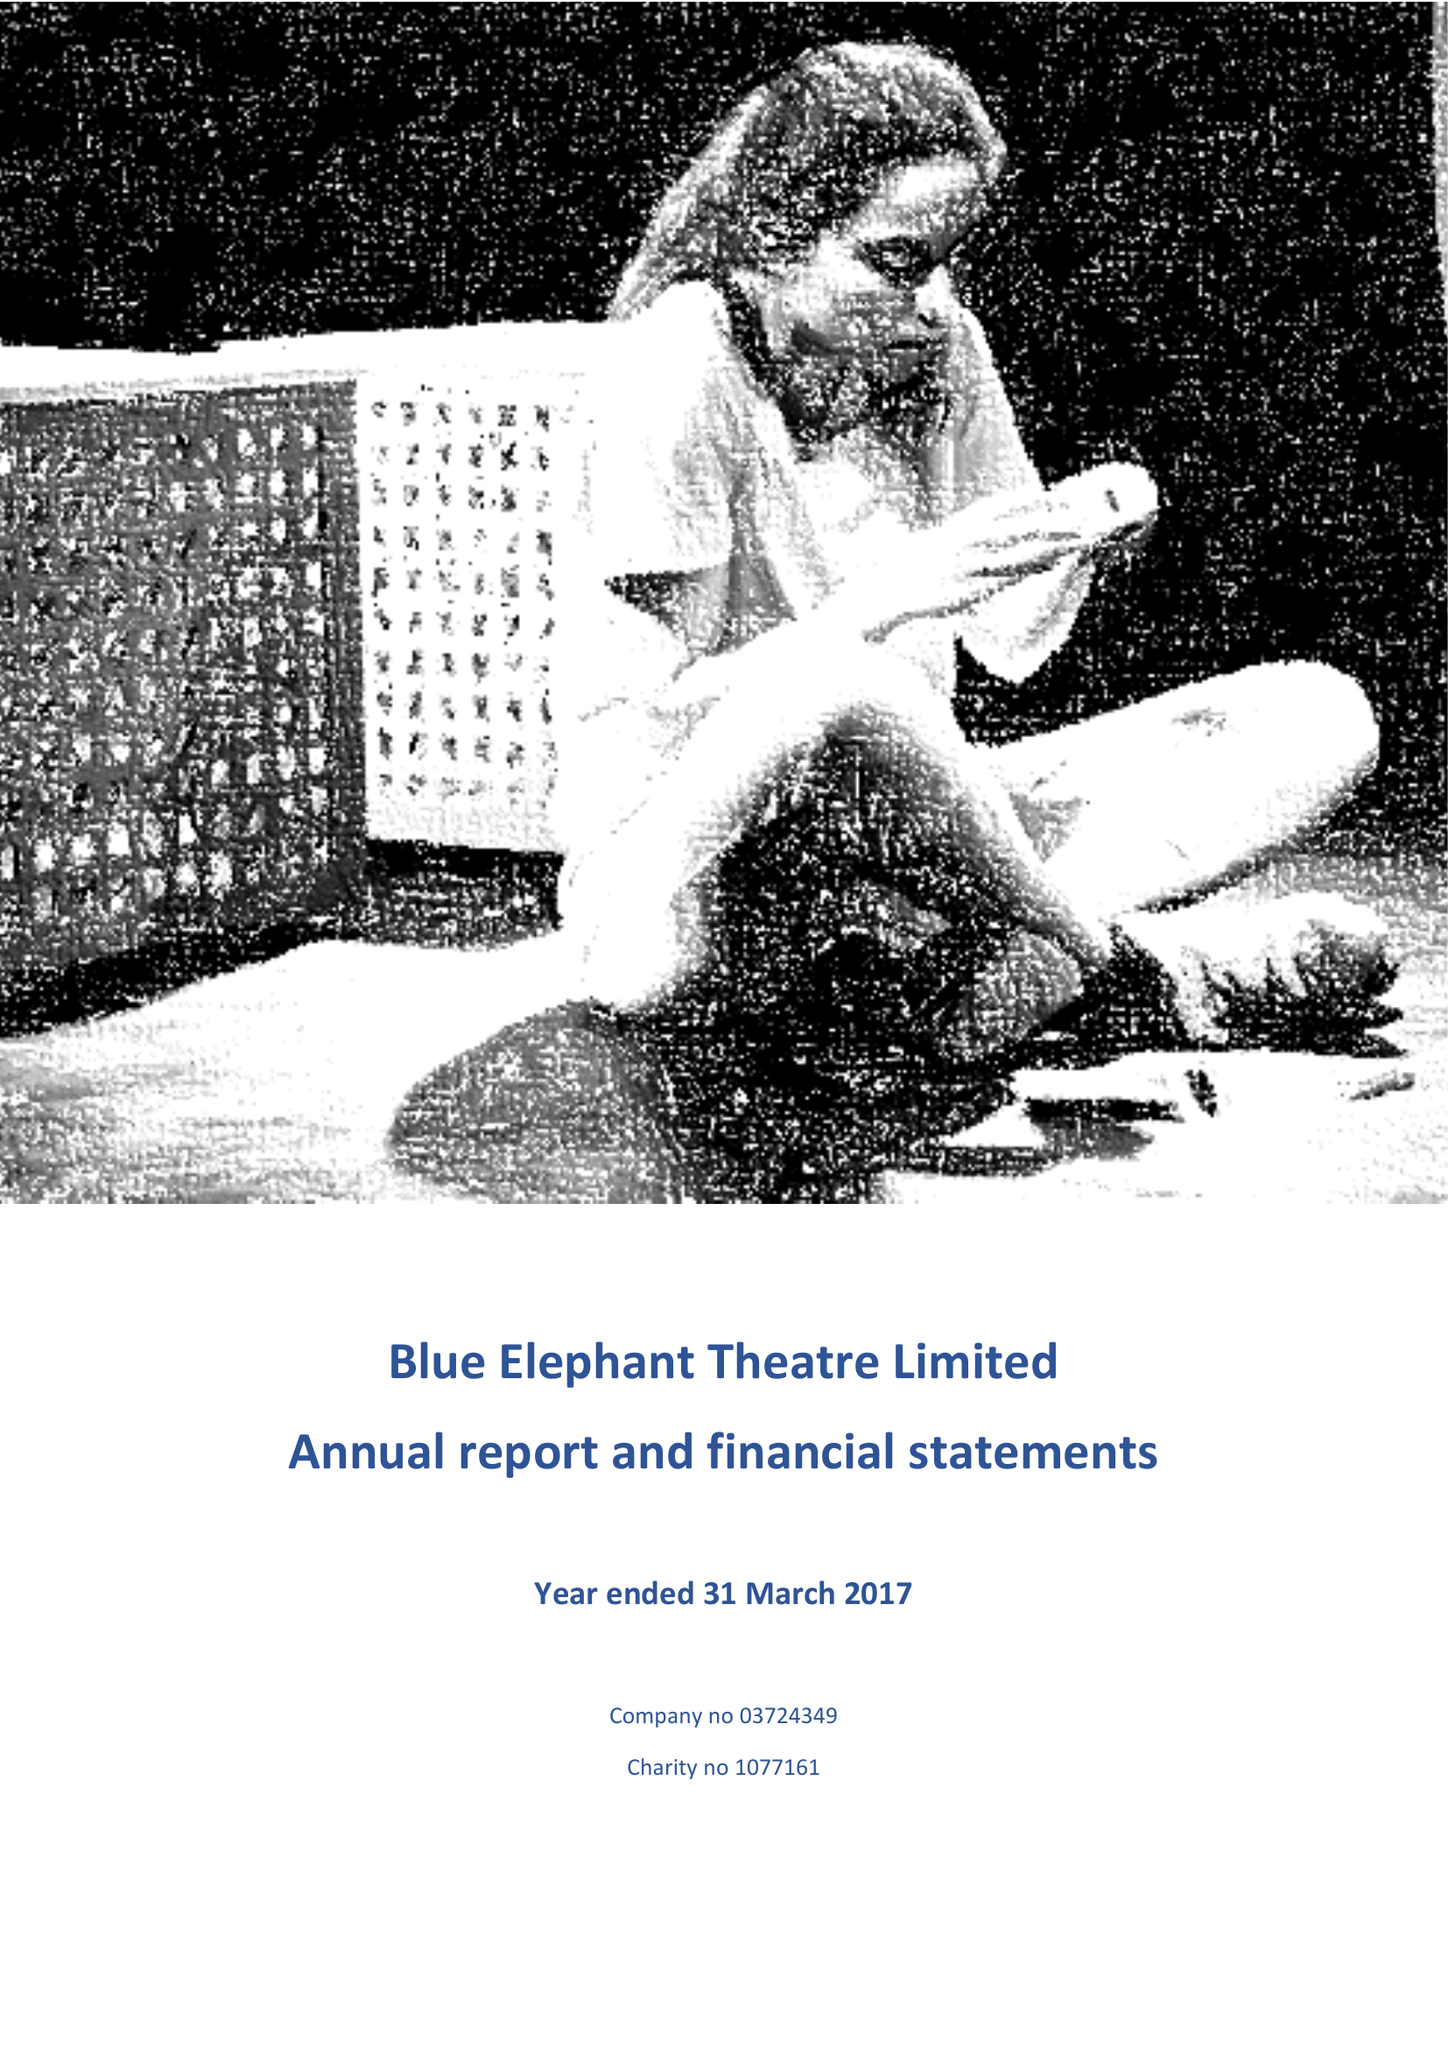What is the value for the charity_number?
Answer the question using a single word or phrase. 1077161 